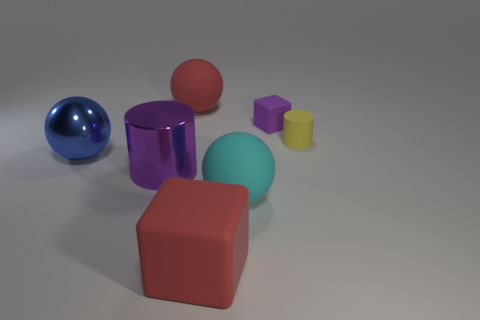There is a tiny object that is the same color as the big metal cylinder; what is its material?
Provide a succinct answer. Rubber. Do the object on the right side of the purple cube and the big ball in front of the blue ball have the same material?
Your answer should be very brief. Yes. Is the number of large blue balls greater than the number of tiny yellow rubber blocks?
Make the answer very short. Yes. What is the color of the large shiny object that is on the left side of the big cylinder right of the metallic object that is to the left of the big purple metal thing?
Provide a short and direct response. Blue. There is a sphere that is behind the large blue metallic object; is its color the same as the cube that is in front of the big metallic cylinder?
Ensure brevity in your answer.  Yes. There is a red ball behind the large cyan sphere; how many small cylinders are in front of it?
Keep it short and to the point. 1. Are any big blue spheres visible?
Your answer should be very brief. Yes. How many other things are there of the same color as the large cylinder?
Offer a terse response. 1. Are there fewer large blue objects than cylinders?
Offer a very short reply. Yes. There is a large red thing behind the large sphere in front of the blue thing; what shape is it?
Keep it short and to the point. Sphere. 